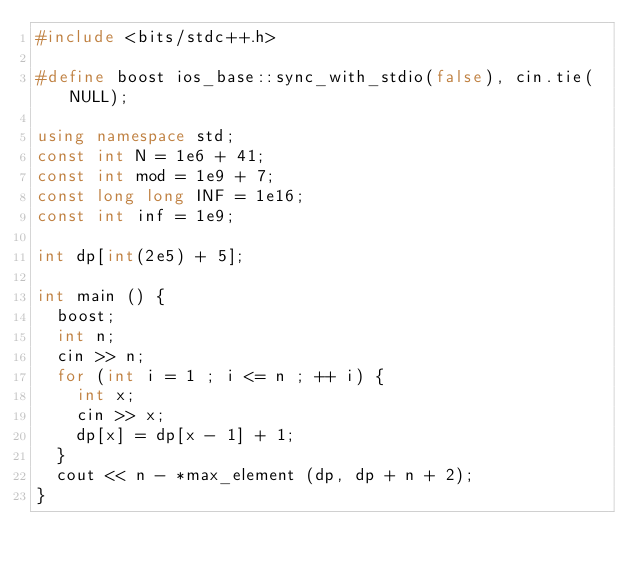Convert code to text. <code><loc_0><loc_0><loc_500><loc_500><_C++_>#include <bits/stdc++.h>

#define boost ios_base::sync_with_stdio(false), cin.tie(NULL);

using namespace std;
const int N = 1e6 + 41;
const int mod = 1e9 + 7;
const long long INF = 1e16;
const int inf = 1e9;

int dp[int(2e5) + 5];

int main () {
	boost;
	int n;
	cin >> n;
	for (int i = 1 ; i <= n ; ++ i) {
		int x;
		cin >> x;
		dp[x] = dp[x - 1] + 1;
	}
	cout << n - *max_element (dp, dp + n + 2);
}</code> 